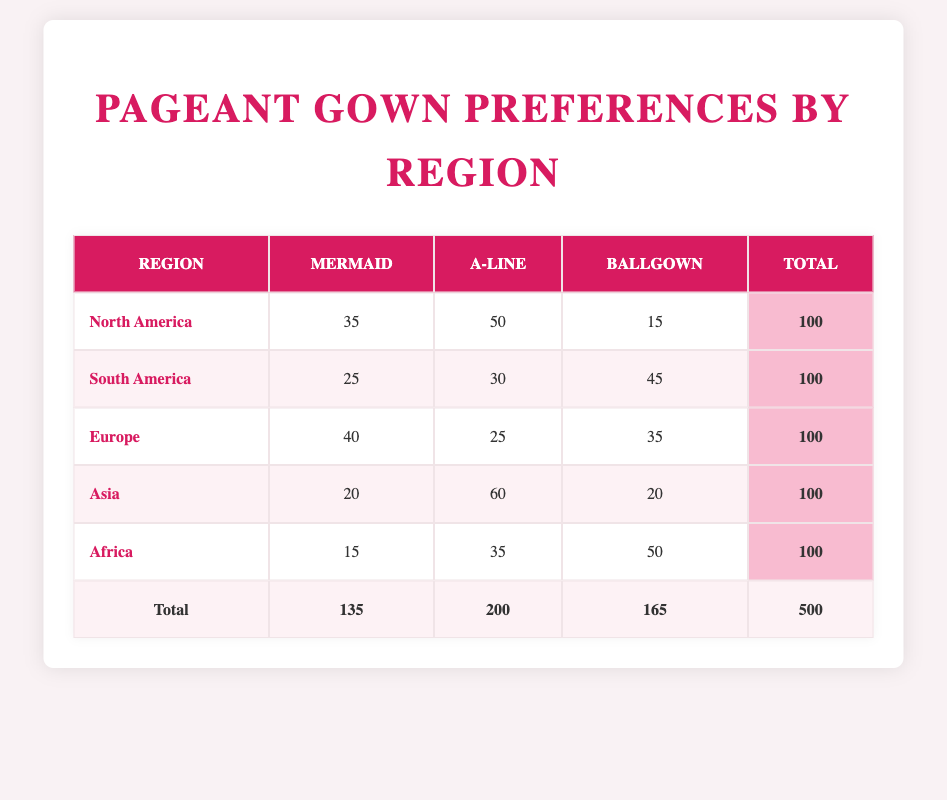What is the highest preference count for gown styles in South America? In South America, the gown styles and their preference counts are as follows: Mermaid (25), A-line (30), and Ballgown (45). The highest preference count is for the Ballgown style with a count of 45.
Answer: 45 Which region has the least preference for the Mermaid gown style? Looking at the table, the preference counts for the Mermaid gown style by region are: North America (35), South America (25), Europe (40), Asia (20), and Africa (15). Africa has the least preference with a count of 15.
Answer: Africa What is the total preference count for A-line gowns across all regions? To find the total preference count for A-line gowns, we add the counts from all regions: North America (50), South America (30), Europe (25), Asia (60), and Africa (35). Adding these gives us 50 + 30 + 25 + 60 + 35 = 200.
Answer: 200 Is the preference count for Ballgown in Asia greater than that in North America? The preference count for Ballgown in Asia is 20, and in North America, it is 15. Since 20 is greater than 15, the statement is true.
Answer: Yes Which gown style is the most popular in Europe based on the preference count? In Europe, the preference counts are as follows: Mermaid (40), A-line (25), and Ballgown (35). The Mermaid style has the highest preference count at 40, making it the most popular in Europe.
Answer: Mermaid What is the difference in preference count for A-line gowns between Asia and South America? In Asia, the preference count for A-line gowns is 60, while in South America, it is 30. The difference is calculated as 60 - 30 = 30.
Answer: 30 Which gown style has the highest total preference count across all regions, and what is that count? We will sum the preference counts for each gown style: Mermaid (135), A-line (200), and Ballgown (165) from all regions. The highest total is for A-line, with a count of 200.
Answer: A-line, 200 How many regions have a preference count greater than 30 for the Ballgown style? The counts for Ballgown style by region are: North America (15), South America (45), Europe (35), Asia (20), and Africa (50). The regions with counts greater than 30 are South America, Europe, and Africa, totaling three regions.
Answer: 3 What is the average preference count for Mermaid gowns across all regions? The total preference count for Mermaid gowns is 135 from all regions (North America 35, South America 25, Europe 40, Asia 20, Africa 15). There are 5 regions, so the average is 135 / 5 = 27.
Answer: 27 